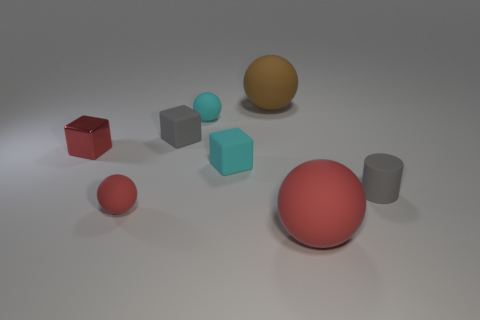Subtract all small red rubber spheres. How many spheres are left? 3 Subtract 1 balls. How many balls are left? 3 Add 1 brown objects. How many objects exist? 9 Subtract all cylinders. How many objects are left? 7 Subtract all red balls. How many balls are left? 2 Subtract all blue balls. How many red cubes are left? 1 Subtract all big brown matte balls. Subtract all blocks. How many objects are left? 4 Add 4 cyan rubber balls. How many cyan rubber balls are left? 5 Add 3 metal things. How many metal things exist? 4 Subtract 0 purple balls. How many objects are left? 8 